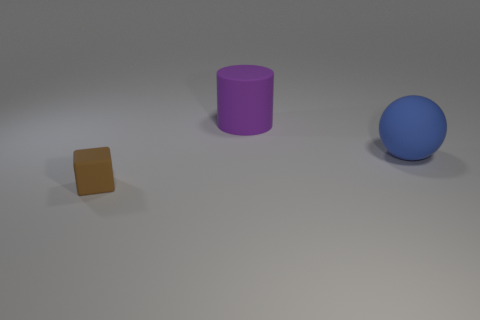How many other objects are there of the same material as the big purple cylinder?
Keep it short and to the point. 2. There is a thing that is left of the blue ball and in front of the cylinder; what size is it?
Your response must be concise. Small. The matte thing in front of the large rubber object in front of the big purple matte thing is what shape?
Ensure brevity in your answer.  Cube. Is there anything else that is the same shape as the blue matte thing?
Keep it short and to the point. No. Are there an equal number of brown blocks on the right side of the blue rubber thing and tiny red shiny balls?
Offer a terse response. Yes. Do the sphere and the rubber thing left of the purple rubber cylinder have the same color?
Keep it short and to the point. No. What color is the rubber object that is both in front of the purple matte cylinder and on the right side of the brown thing?
Provide a succinct answer. Blue. What number of brown matte cubes are behind the object behind the big blue thing?
Provide a short and direct response. 0. Are there any other tiny rubber things that have the same shape as the blue thing?
Make the answer very short. No. Are there the same number of small blue things and brown matte objects?
Keep it short and to the point. No. 